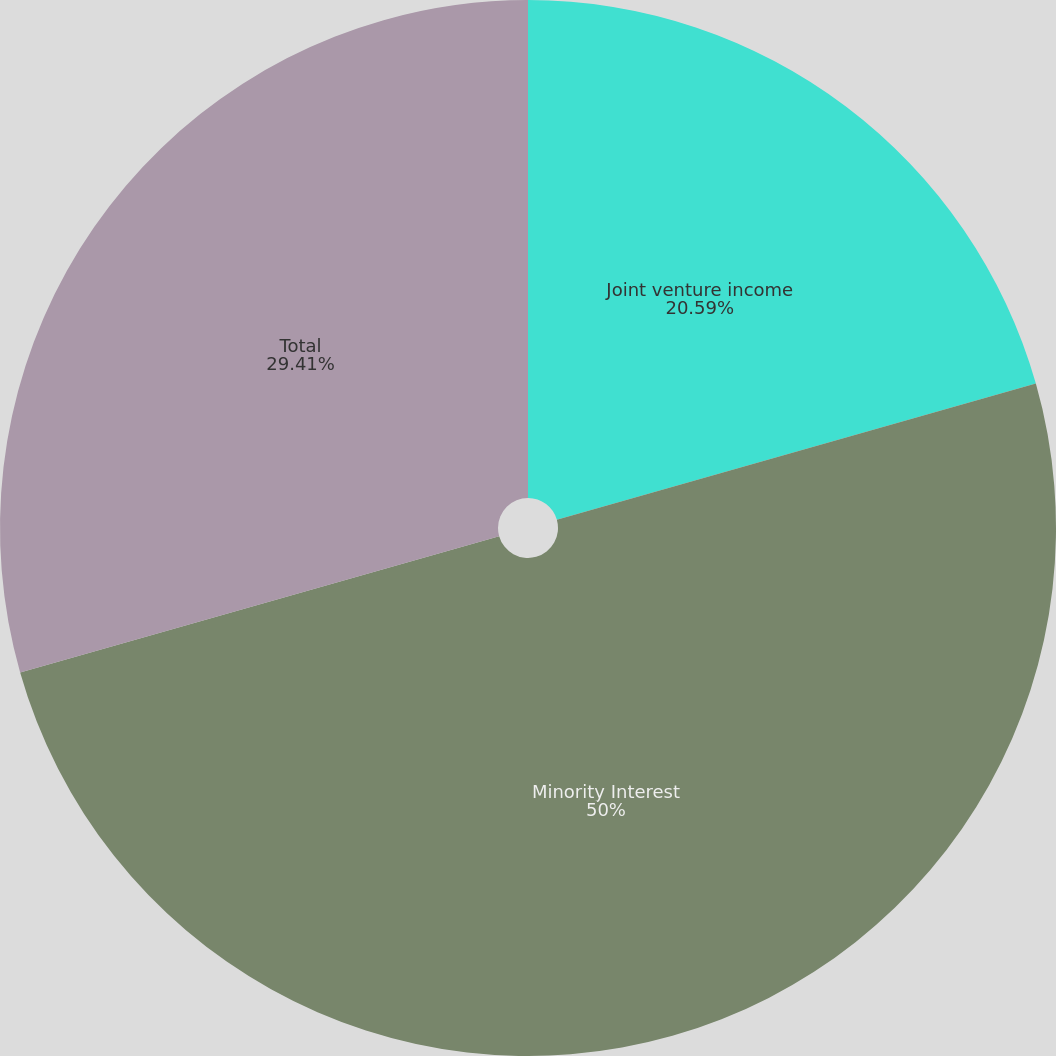Convert chart to OTSL. <chart><loc_0><loc_0><loc_500><loc_500><pie_chart><fcel>Joint venture income<fcel>Minority Interest<fcel>Total<nl><fcel>20.59%<fcel>50.0%<fcel>29.41%<nl></chart> 